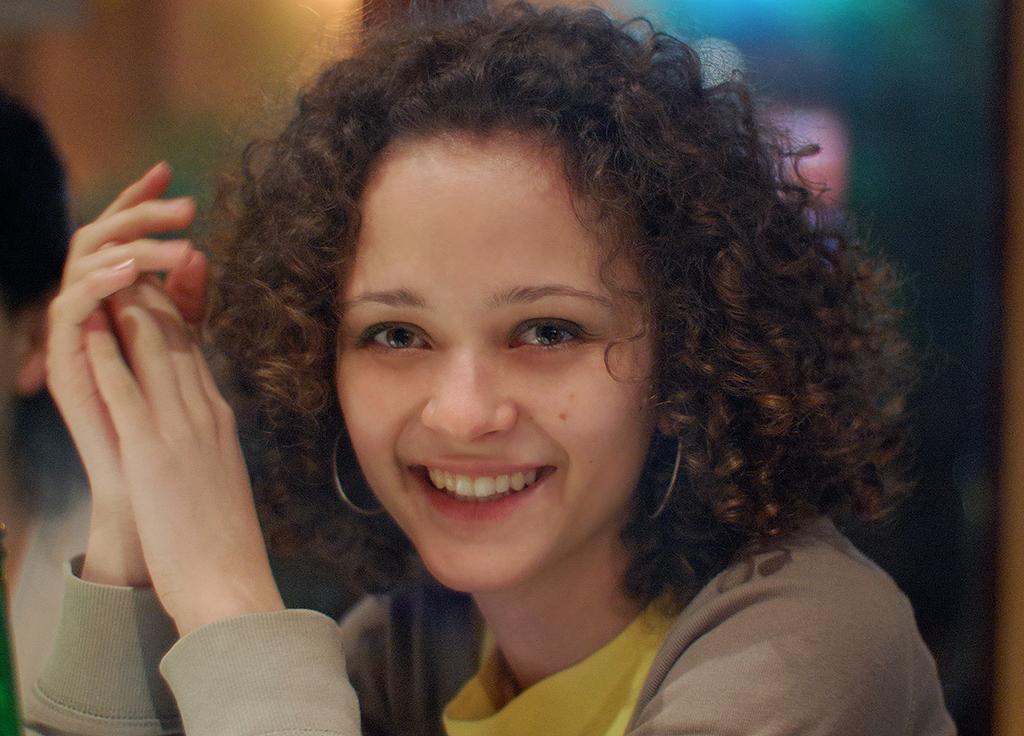Can you describe this image briefly? In this image, I can see a woman smiling. There is a blurred background. On the left corner of the image, I can see another person. 